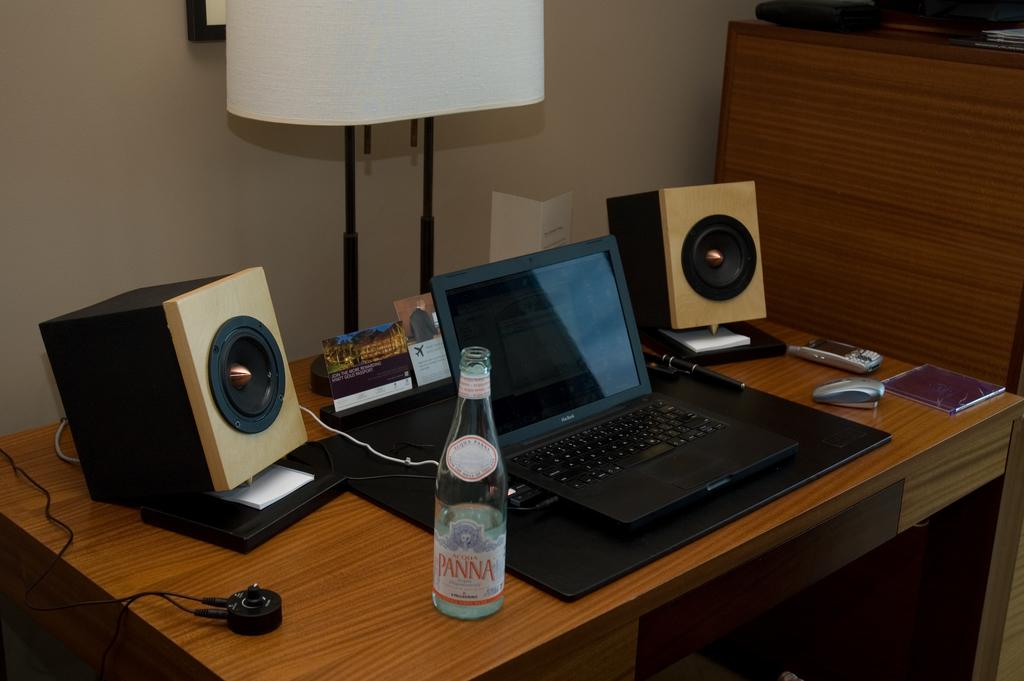What is the main piece of furniture in the image? There is a table in the image. What is placed on the table? There is a mobile, a mouse, two speakers, a bottle, a laptop, a pen, and other objects on the table. Can you describe any lighting source in the image? There is a lamp in the image. What is the background of the image? There is a wall in the image. Are there any decorative items in the image? Yes, there is a photo frame in the image. What time of day is it in the image, and is there a seat available for someone to sit? The time of day is not mentioned in the image, and there is no information about a seat available for someone to sit. 